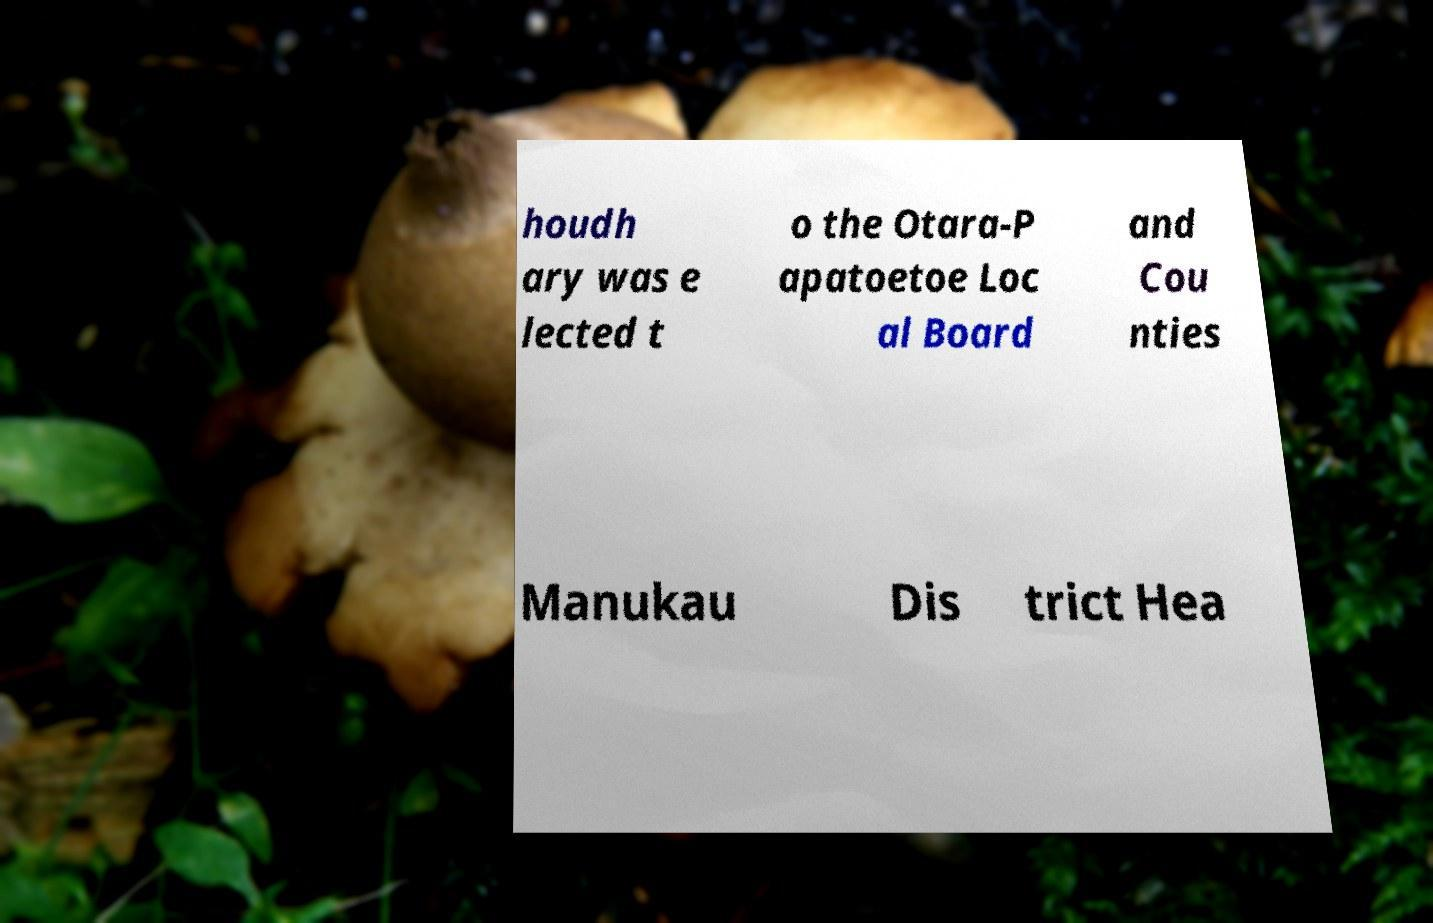I need the written content from this picture converted into text. Can you do that? houdh ary was e lected t o the Otara-P apatoetoe Loc al Board and Cou nties Manukau Dis trict Hea 